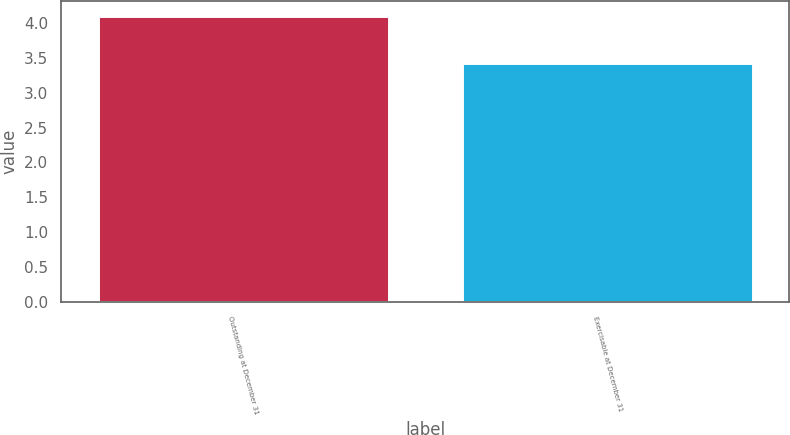<chart> <loc_0><loc_0><loc_500><loc_500><bar_chart><fcel>Outstanding at December 31<fcel>Exercisable at December 31<nl><fcel>4.1<fcel>3.42<nl></chart> 